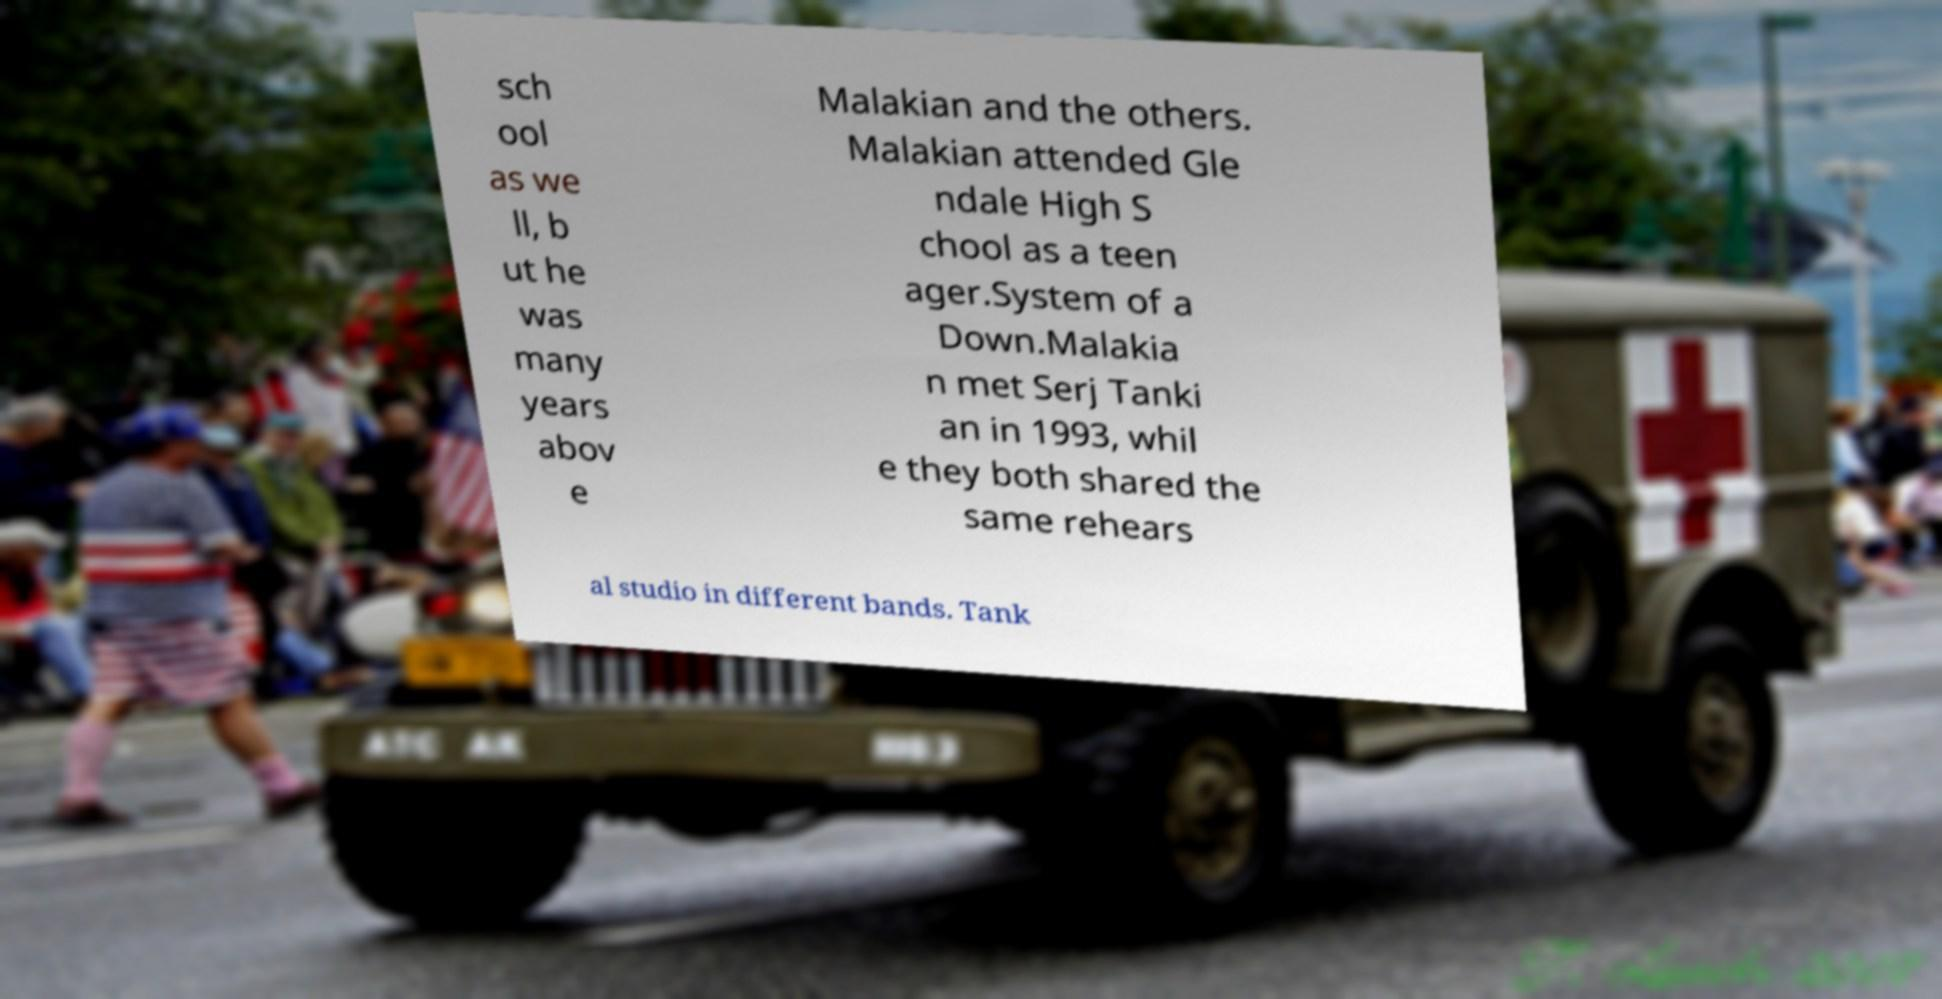For documentation purposes, I need the text within this image transcribed. Could you provide that? sch ool as we ll, b ut he was many years abov e Malakian and the others. Malakian attended Gle ndale High S chool as a teen ager.System of a Down.Malakia n met Serj Tanki an in 1993, whil e they both shared the same rehears al studio in different bands. Tank 